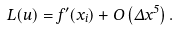<formula> <loc_0><loc_0><loc_500><loc_500>L ( u ) = f ^ { \prime } ( x _ { i } ) + O \left ( \Delta x ^ { 5 } \right ) .</formula> 